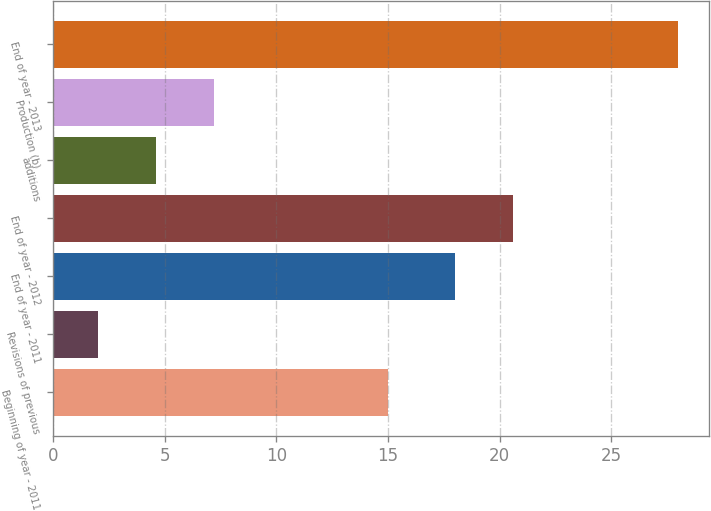Convert chart to OTSL. <chart><loc_0><loc_0><loc_500><loc_500><bar_chart><fcel>Beginning of year - 2011<fcel>Revisions of previous<fcel>End of year - 2011<fcel>End of year - 2012<fcel>additions<fcel>Production (b)<fcel>End of year - 2013<nl><fcel>15<fcel>2<fcel>18<fcel>20.6<fcel>4.6<fcel>7.2<fcel>28<nl></chart> 